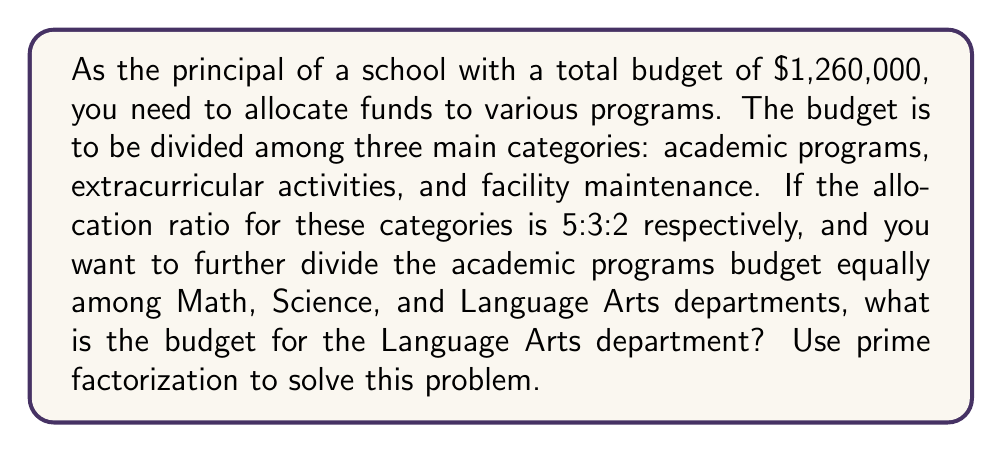Could you help me with this problem? Let's approach this problem step-by-step using prime factorization:

1) First, let's factorize the total budget:
   $1,260,000 = 2^6 \times 3^2 \times 5^3 \times 7$

2) The ratio for budget allocation is 5:3:2, which sums to 10. We need to divide the total budget by 10 and then multiply by the respective parts:

   Academic programs: $\frac{5}{10} \times 1,260,000 = 630,000$
   Extracurricular activities: $\frac{3}{10} \times 1,260,000 = 378,000$
   Facility maintenance: $\frac{2}{10} \times 1,260,000 = 252,000$

3) We're interested in the academic programs budget: $630,000

4) Let's factorize this:
   $630,000 = 2^5 \times 3^2 \times 5^3 \times 7$

5) The academic budget needs to be divided equally among three departments (Math, Science, and Language Arts). So we need to divide this by 3:

   $\frac{630,000}{3} = \frac{2^5 \times 3^2 \times 5^3 \times 7}{3}$

6) Simplifying:
   $2^5 \times 3 \times 5^3 \times 7 = 210,000$

Therefore, the budget for the Language Arts department is $210,000.
Answer: $210,000 